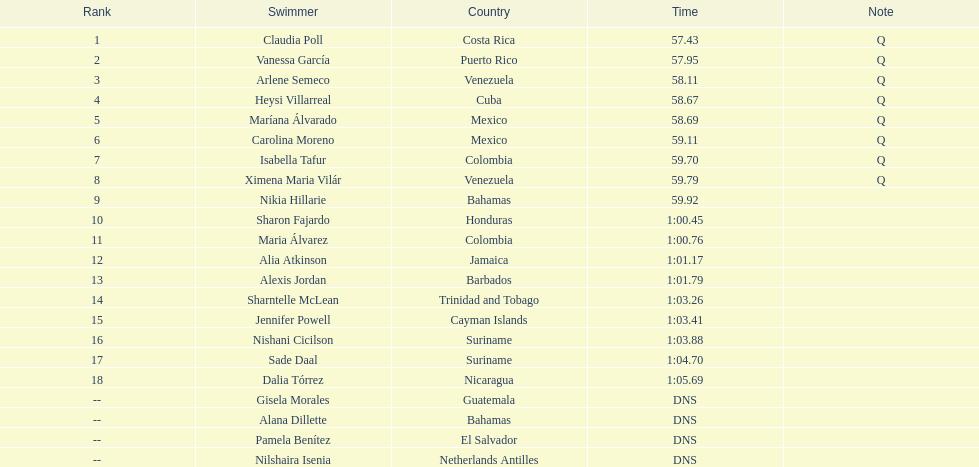How many mexican swimmers are there? 2. 